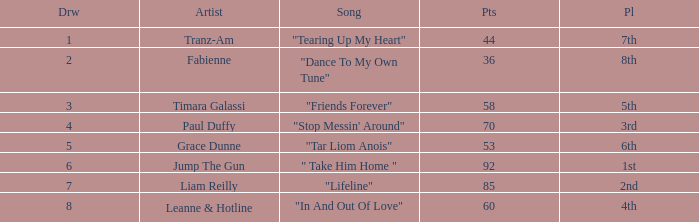What's the total number of points for grace dunne with a draw over 5? 0.0. 